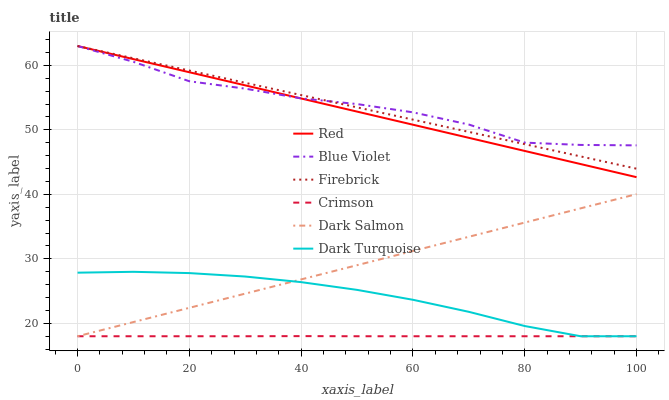Does Firebrick have the minimum area under the curve?
Answer yes or no. No. Does Firebrick have the maximum area under the curve?
Answer yes or no. No. Is Firebrick the smoothest?
Answer yes or no. No. Is Firebrick the roughest?
Answer yes or no. No. Does Firebrick have the lowest value?
Answer yes or no. No. Does Dark Salmon have the highest value?
Answer yes or no. No. Is Crimson less than Firebrick?
Answer yes or no. Yes. Is Blue Violet greater than Crimson?
Answer yes or no. Yes. Does Crimson intersect Firebrick?
Answer yes or no. No. 